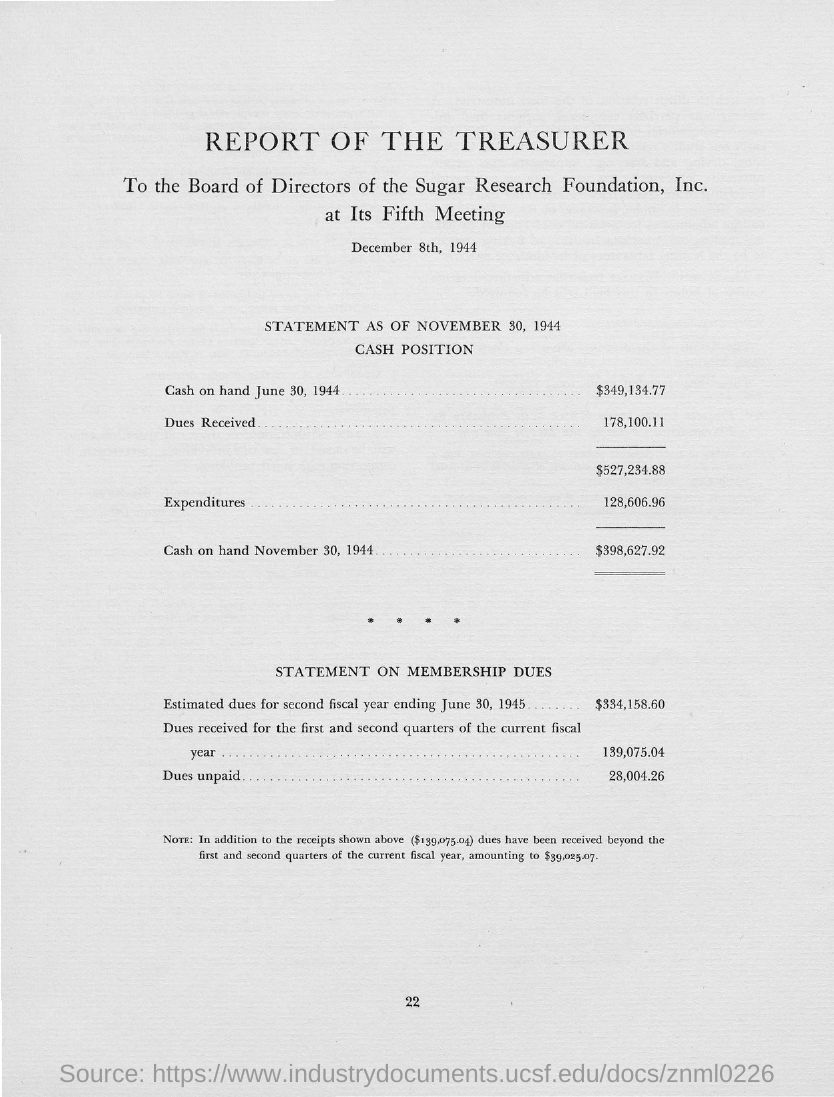What is the cash on hand on June 30, 1944 given in the statement?
Offer a terse response. $349,134.77. What is the expenditure as per the statement?
Make the answer very short. $128,606.96. What is the cash on hand on November 30, 1944 given in the statement?
Your answer should be compact. $398,627.92. What is the estimated dues for second fiscal year ending June 30, 1945?
Your answer should be compact. $334,158.60. What are the dues received for the first and second quarters of the current fiscal year?
Make the answer very short. 139,075.04. 